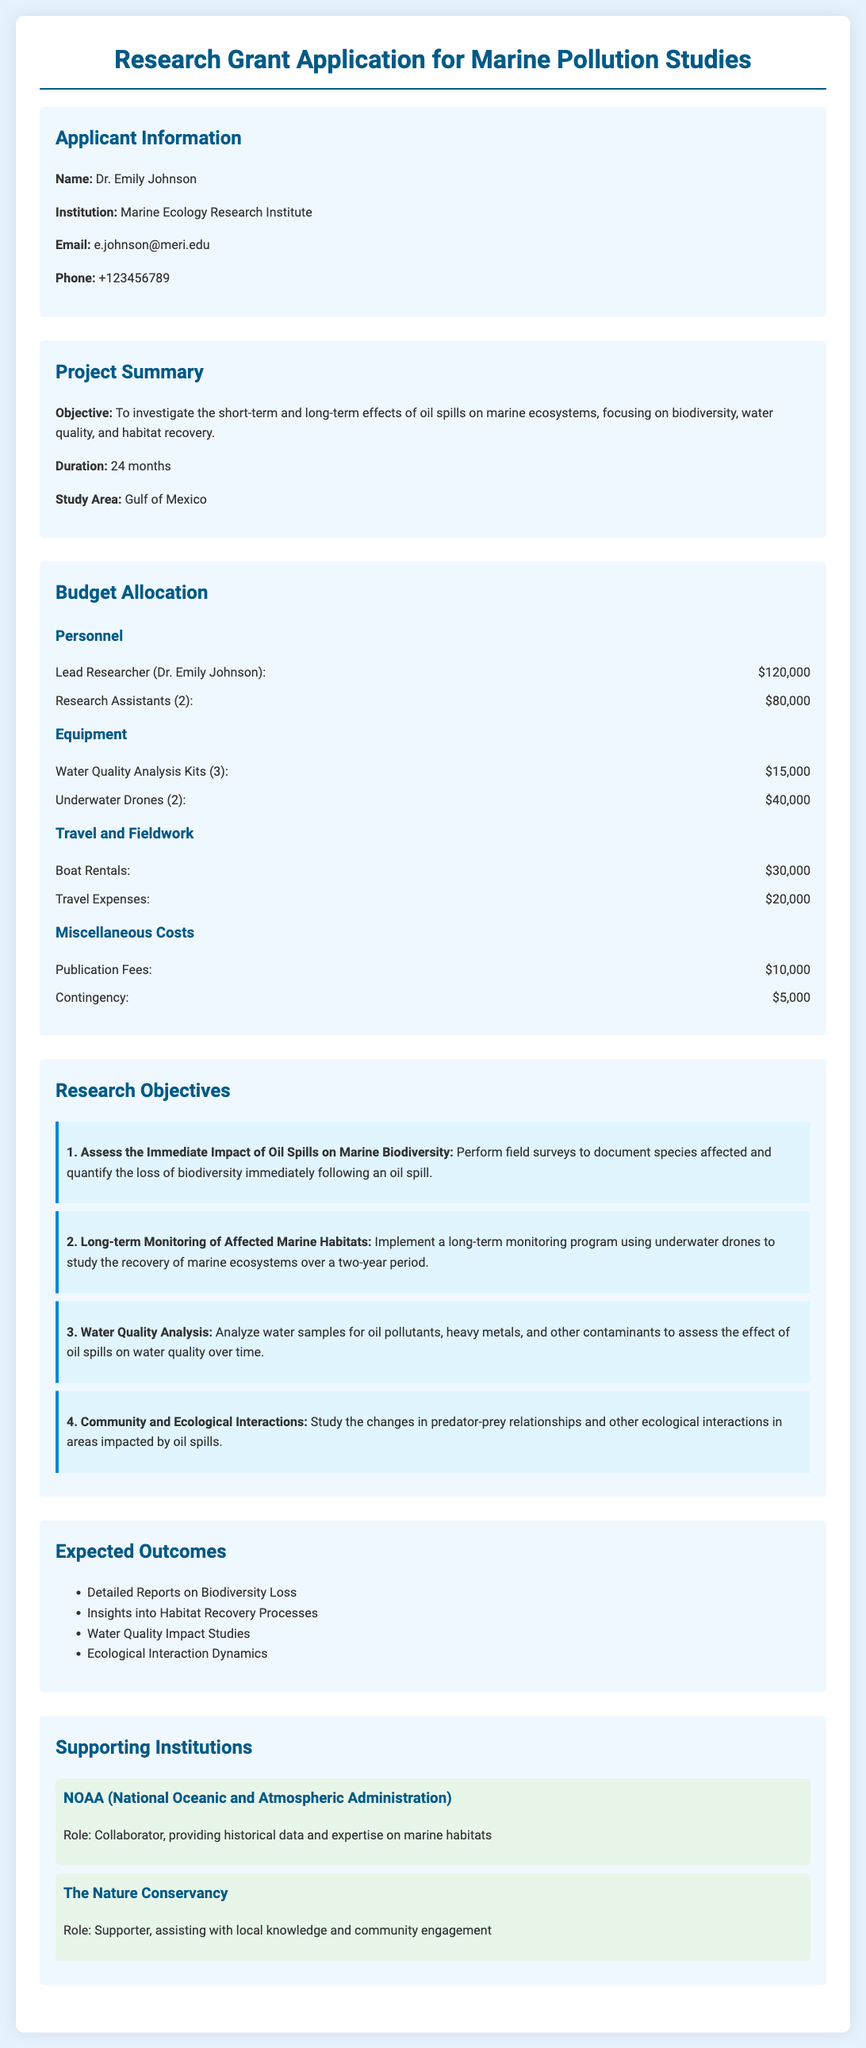What is the name of the applicant? The applicant's name is mentioned in the "Applicant Information" section of the document.
Answer: Dr. Emily Johnson What is the total budget for personnel? The total budget for personnel is calculated by adding the lead researcher's salary and the research assistants' salaries, which is $120,000 + $80,000.
Answer: $200,000 How long is the project duration? The project duration is specified in the "Project Summary" section of the document.
Answer: 24 months What is the study area for the research? The study area is indicated in the "Project Summary" section of the document.
Answer: Gulf of Mexico What is the cost of underwater drones? The cost of underwater drones is listed in the "Budget Allocation" section under Equipment.
Answer: $40,000 How many research assistants are proposed in the team? The number of research assistants is mentioned in the budget allocation for personnel.
Answer: 2 What is one expected outcome of the research? Expected outcomes are listed in the "Expected Outcomes" section, and one example can be directly cited.
Answer: Detailed Reports on Biodiversity Loss Which institution is collaborating with the project? The collaborating institution is specified in the "Supporting Institutions" section of the document.
Answer: NOAA (National Oceanic and Atmospheric Administration) What is the role of The Nature Conservancy in this research? The role of The Nature Conservancy is defined in the "Supporting Institutions" section.
Answer: Supporter 